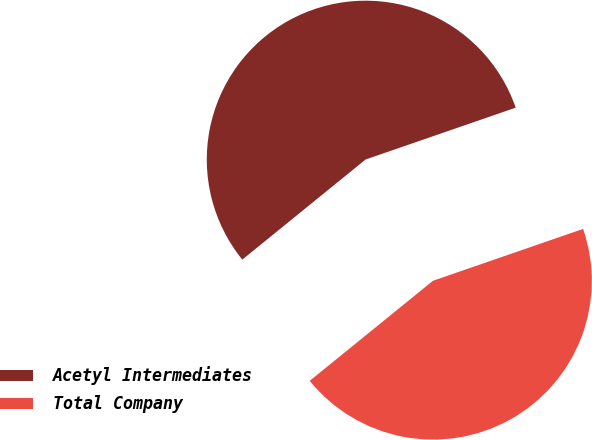Convert chart. <chart><loc_0><loc_0><loc_500><loc_500><pie_chart><fcel>Acetyl Intermediates<fcel>Total Company<nl><fcel>55.56%<fcel>44.44%<nl></chart> 